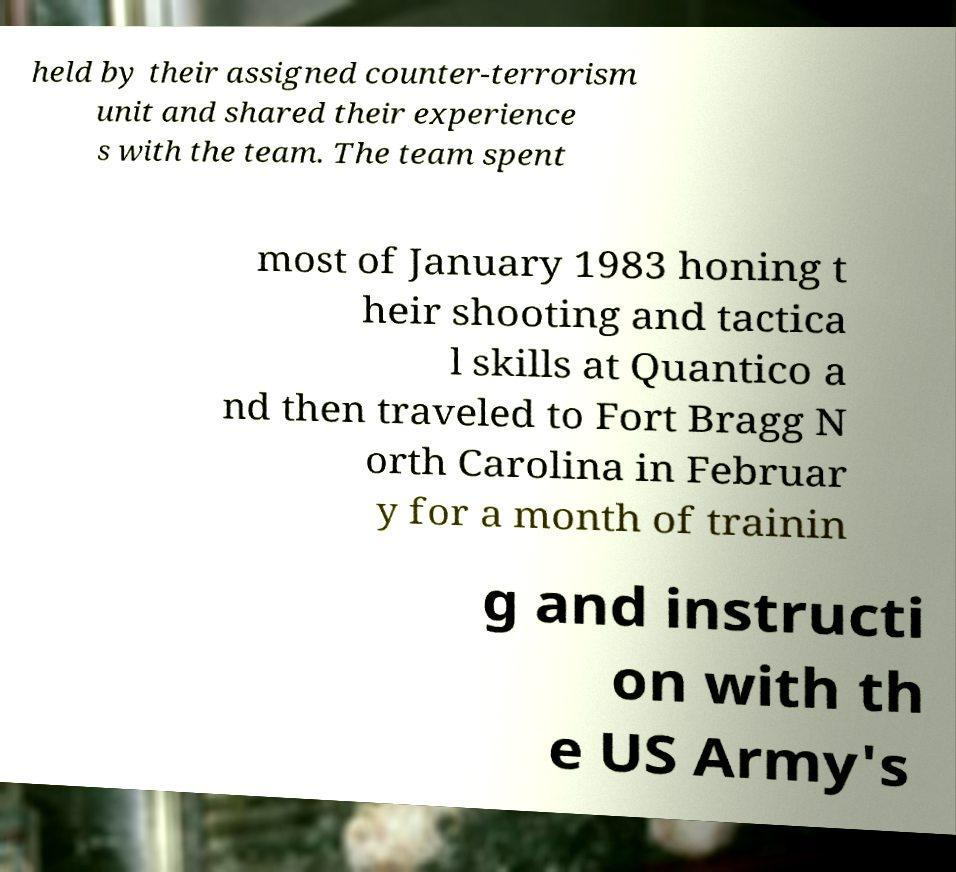What messages or text are displayed in this image? I need them in a readable, typed format. held by their assigned counter-terrorism unit and shared their experience s with the team. The team spent most of January 1983 honing t heir shooting and tactica l skills at Quantico a nd then traveled to Fort Bragg N orth Carolina in Februar y for a month of trainin g and instructi on with th e US Army's 